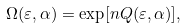Convert formula to latex. <formula><loc_0><loc_0><loc_500><loc_500>\Omega ( \varepsilon , \alpha ) = \exp [ n Q ( \varepsilon , \alpha ) ] ,</formula> 